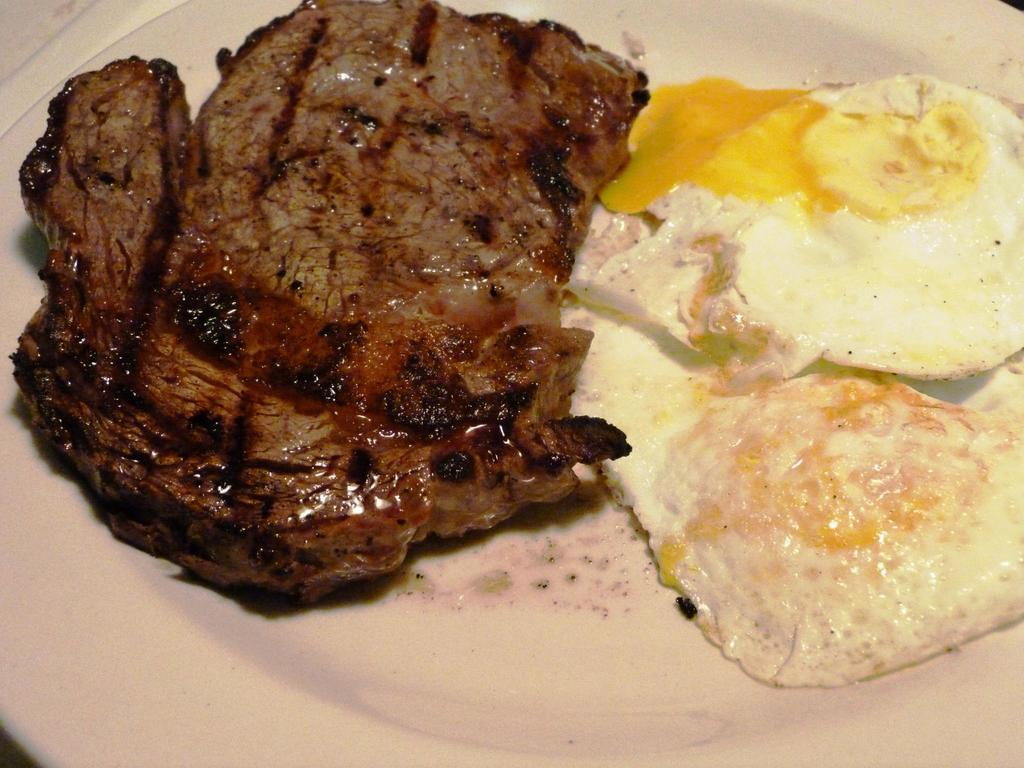What is the color of the plate in the image? The plate in the image is white colored. What is on the plate? There are two omelets and a piece of meat on the plate. Can you describe the appearance of the omelets? The omelets are yellow and cream in color. How would you describe the appearance of the piece of meat? The piece of meat is black and brown in color. Where is the harbor located in the image? There is no harbor present in the image. Can you see a snake in the image? There is no snake present in the image. 